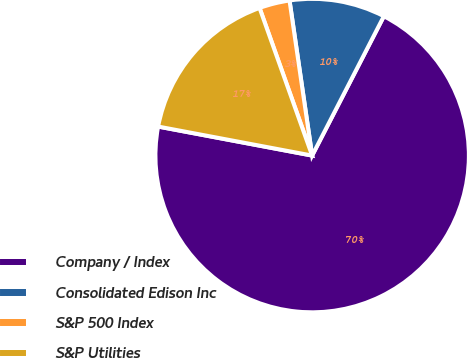Convert chart. <chart><loc_0><loc_0><loc_500><loc_500><pie_chart><fcel>Company / Index<fcel>Consolidated Edison Inc<fcel>S&P 500 Index<fcel>S&P Utilities<nl><fcel>70.4%<fcel>9.87%<fcel>3.14%<fcel>16.59%<nl></chart> 